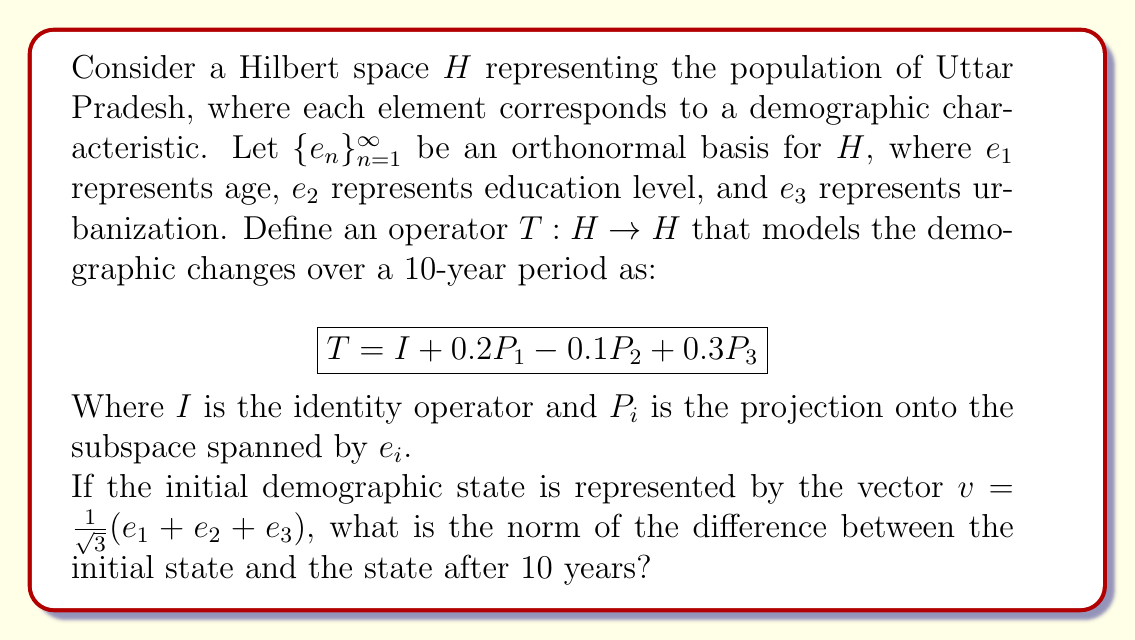Can you solve this math problem? To solve this problem, we need to follow these steps:

1) First, let's apply the operator $T$ to the initial state $v$:

   $$Tv = (I + 0.2P_1 - 0.1P_2 + 0.3P_3)(\frac{1}{\sqrt{3}}(e_1 + e_2 + e_3))$$

2) Distribute the operator:

   $$Tv = \frac{1}{\sqrt{3}}(e_1 + e_2 + e_3) + \frac{0.2}{\sqrt{3}}e_1 - \frac{0.1}{\sqrt{3}}e_2 + \frac{0.3}{\sqrt{3}}e_3$$

3) Combine like terms:

   $$Tv = \frac{1}{\sqrt{3}}(1.2e_1 + 0.9e_2 + 1.3e_3)$$

4) Now, we need to find the difference between $Tv$ and $v$:

   $$Tv - v = \frac{1}{\sqrt{3}}(1.2e_1 + 0.9e_2 + 1.3e_3) - \frac{1}{\sqrt{3}}(e_1 + e_2 + e_3)$$
   
   $$= \frac{1}{\sqrt{3}}(0.2e_1 - 0.1e_2 + 0.3e_3)$$

5) To find the norm of this difference, we calculate:

   $$\|Tv - v\|^2 = (\frac{1}{\sqrt{3}})^2(0.2^2 + (-0.1)^2 + 0.3^2)$$

   $$= \frac{1}{3}(0.04 + 0.01 + 0.09) = \frac{0.14}{3}$$

6) Taking the square root:

   $$\|Tv - v\| = \sqrt{\frac{0.14}{3}} = \frac{\sqrt{0.14}}{\sqrt{3}}$$
Answer: The norm of the difference between the initial state and the state after 10 years is $\frac{\sqrt{0.14}}{\sqrt{3}} \approx 0.2160$. 